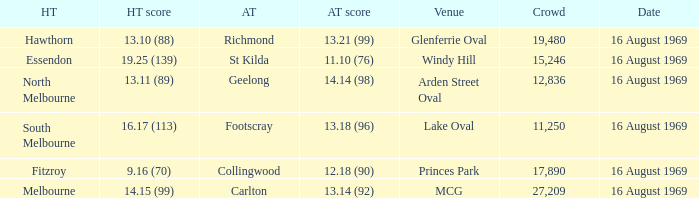When was the game played at Lake Oval? 16 August 1969. 